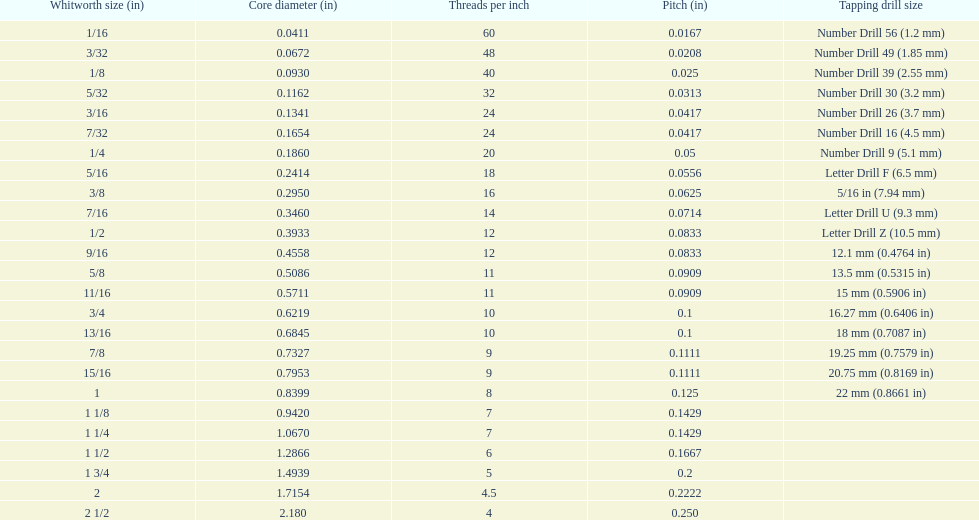How many more threads per inch does the 1/16th whitworth size have over the 1/8th whitworth size? 20. 